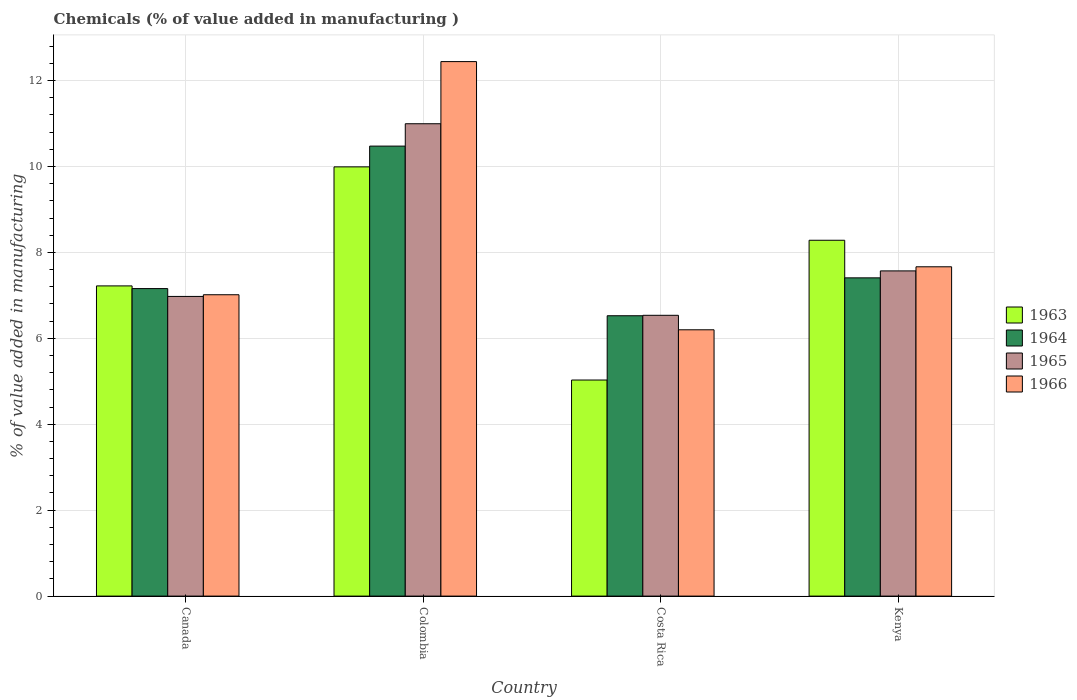How many groups of bars are there?
Your answer should be compact. 4. Are the number of bars per tick equal to the number of legend labels?
Make the answer very short. Yes. Are the number of bars on each tick of the X-axis equal?
Offer a very short reply. Yes. What is the label of the 3rd group of bars from the left?
Offer a very short reply. Costa Rica. What is the value added in manufacturing chemicals in 1964 in Costa Rica?
Offer a terse response. 6.53. Across all countries, what is the maximum value added in manufacturing chemicals in 1966?
Provide a succinct answer. 12.44. Across all countries, what is the minimum value added in manufacturing chemicals in 1965?
Your answer should be compact. 6.54. In which country was the value added in manufacturing chemicals in 1963 maximum?
Your answer should be compact. Colombia. What is the total value added in manufacturing chemicals in 1965 in the graph?
Give a very brief answer. 32.08. What is the difference between the value added in manufacturing chemicals in 1963 in Colombia and that in Kenya?
Your answer should be compact. 1.71. What is the difference between the value added in manufacturing chemicals in 1963 in Canada and the value added in manufacturing chemicals in 1964 in Costa Rica?
Provide a short and direct response. 0.69. What is the average value added in manufacturing chemicals in 1963 per country?
Ensure brevity in your answer.  7.63. What is the difference between the value added in manufacturing chemicals of/in 1966 and value added in manufacturing chemicals of/in 1964 in Kenya?
Make the answer very short. 0.26. What is the ratio of the value added in manufacturing chemicals in 1965 in Canada to that in Costa Rica?
Offer a terse response. 1.07. Is the value added in manufacturing chemicals in 1964 in Colombia less than that in Costa Rica?
Give a very brief answer. No. What is the difference between the highest and the second highest value added in manufacturing chemicals in 1966?
Give a very brief answer. -5.43. What is the difference between the highest and the lowest value added in manufacturing chemicals in 1965?
Provide a short and direct response. 4.46. What does the 4th bar from the left in Costa Rica represents?
Offer a very short reply. 1966. What does the 4th bar from the right in Costa Rica represents?
Provide a short and direct response. 1963. How many bars are there?
Your answer should be very brief. 16. How many countries are there in the graph?
Provide a short and direct response. 4. Are the values on the major ticks of Y-axis written in scientific E-notation?
Give a very brief answer. No. Does the graph contain any zero values?
Provide a succinct answer. No. Does the graph contain grids?
Provide a short and direct response. Yes. Where does the legend appear in the graph?
Keep it short and to the point. Center right. How many legend labels are there?
Offer a very short reply. 4. What is the title of the graph?
Offer a terse response. Chemicals (% of value added in manufacturing ). Does "1986" appear as one of the legend labels in the graph?
Offer a terse response. No. What is the label or title of the Y-axis?
Keep it short and to the point. % of value added in manufacturing. What is the % of value added in manufacturing of 1963 in Canada?
Ensure brevity in your answer.  7.22. What is the % of value added in manufacturing of 1964 in Canada?
Keep it short and to the point. 7.16. What is the % of value added in manufacturing of 1965 in Canada?
Ensure brevity in your answer.  6.98. What is the % of value added in manufacturing in 1966 in Canada?
Provide a succinct answer. 7.01. What is the % of value added in manufacturing of 1963 in Colombia?
Offer a very short reply. 9.99. What is the % of value added in manufacturing of 1964 in Colombia?
Give a very brief answer. 10.47. What is the % of value added in manufacturing in 1965 in Colombia?
Give a very brief answer. 10.99. What is the % of value added in manufacturing in 1966 in Colombia?
Provide a short and direct response. 12.44. What is the % of value added in manufacturing of 1963 in Costa Rica?
Your response must be concise. 5.03. What is the % of value added in manufacturing in 1964 in Costa Rica?
Provide a short and direct response. 6.53. What is the % of value added in manufacturing of 1965 in Costa Rica?
Your response must be concise. 6.54. What is the % of value added in manufacturing of 1966 in Costa Rica?
Your answer should be very brief. 6.2. What is the % of value added in manufacturing in 1963 in Kenya?
Ensure brevity in your answer.  8.28. What is the % of value added in manufacturing in 1964 in Kenya?
Provide a short and direct response. 7.41. What is the % of value added in manufacturing of 1965 in Kenya?
Give a very brief answer. 7.57. What is the % of value added in manufacturing of 1966 in Kenya?
Ensure brevity in your answer.  7.67. Across all countries, what is the maximum % of value added in manufacturing of 1963?
Offer a terse response. 9.99. Across all countries, what is the maximum % of value added in manufacturing of 1964?
Your answer should be very brief. 10.47. Across all countries, what is the maximum % of value added in manufacturing in 1965?
Provide a succinct answer. 10.99. Across all countries, what is the maximum % of value added in manufacturing of 1966?
Ensure brevity in your answer.  12.44. Across all countries, what is the minimum % of value added in manufacturing of 1963?
Keep it short and to the point. 5.03. Across all countries, what is the minimum % of value added in manufacturing of 1964?
Your answer should be compact. 6.53. Across all countries, what is the minimum % of value added in manufacturing in 1965?
Provide a short and direct response. 6.54. Across all countries, what is the minimum % of value added in manufacturing in 1966?
Provide a short and direct response. 6.2. What is the total % of value added in manufacturing of 1963 in the graph?
Ensure brevity in your answer.  30.52. What is the total % of value added in manufacturing of 1964 in the graph?
Your response must be concise. 31.57. What is the total % of value added in manufacturing of 1965 in the graph?
Provide a short and direct response. 32.08. What is the total % of value added in manufacturing in 1966 in the graph?
Ensure brevity in your answer.  33.32. What is the difference between the % of value added in manufacturing of 1963 in Canada and that in Colombia?
Provide a succinct answer. -2.77. What is the difference between the % of value added in manufacturing of 1964 in Canada and that in Colombia?
Keep it short and to the point. -3.32. What is the difference between the % of value added in manufacturing of 1965 in Canada and that in Colombia?
Your answer should be very brief. -4.02. What is the difference between the % of value added in manufacturing of 1966 in Canada and that in Colombia?
Give a very brief answer. -5.43. What is the difference between the % of value added in manufacturing in 1963 in Canada and that in Costa Rica?
Make the answer very short. 2.19. What is the difference between the % of value added in manufacturing in 1964 in Canada and that in Costa Rica?
Your answer should be very brief. 0.63. What is the difference between the % of value added in manufacturing in 1965 in Canada and that in Costa Rica?
Give a very brief answer. 0.44. What is the difference between the % of value added in manufacturing in 1966 in Canada and that in Costa Rica?
Offer a very short reply. 0.82. What is the difference between the % of value added in manufacturing of 1963 in Canada and that in Kenya?
Offer a very short reply. -1.06. What is the difference between the % of value added in manufacturing in 1964 in Canada and that in Kenya?
Your answer should be compact. -0.25. What is the difference between the % of value added in manufacturing in 1965 in Canada and that in Kenya?
Your response must be concise. -0.59. What is the difference between the % of value added in manufacturing in 1966 in Canada and that in Kenya?
Your answer should be very brief. -0.65. What is the difference between the % of value added in manufacturing of 1963 in Colombia and that in Costa Rica?
Your answer should be compact. 4.96. What is the difference between the % of value added in manufacturing in 1964 in Colombia and that in Costa Rica?
Offer a very short reply. 3.95. What is the difference between the % of value added in manufacturing in 1965 in Colombia and that in Costa Rica?
Make the answer very short. 4.46. What is the difference between the % of value added in manufacturing in 1966 in Colombia and that in Costa Rica?
Offer a terse response. 6.24. What is the difference between the % of value added in manufacturing in 1963 in Colombia and that in Kenya?
Provide a short and direct response. 1.71. What is the difference between the % of value added in manufacturing of 1964 in Colombia and that in Kenya?
Offer a very short reply. 3.07. What is the difference between the % of value added in manufacturing of 1965 in Colombia and that in Kenya?
Your response must be concise. 3.43. What is the difference between the % of value added in manufacturing of 1966 in Colombia and that in Kenya?
Give a very brief answer. 4.78. What is the difference between the % of value added in manufacturing of 1963 in Costa Rica and that in Kenya?
Your response must be concise. -3.25. What is the difference between the % of value added in manufacturing of 1964 in Costa Rica and that in Kenya?
Give a very brief answer. -0.88. What is the difference between the % of value added in manufacturing in 1965 in Costa Rica and that in Kenya?
Offer a terse response. -1.03. What is the difference between the % of value added in manufacturing of 1966 in Costa Rica and that in Kenya?
Your answer should be compact. -1.47. What is the difference between the % of value added in manufacturing in 1963 in Canada and the % of value added in manufacturing in 1964 in Colombia?
Your response must be concise. -3.25. What is the difference between the % of value added in manufacturing of 1963 in Canada and the % of value added in manufacturing of 1965 in Colombia?
Provide a succinct answer. -3.77. What is the difference between the % of value added in manufacturing of 1963 in Canada and the % of value added in manufacturing of 1966 in Colombia?
Your response must be concise. -5.22. What is the difference between the % of value added in manufacturing in 1964 in Canada and the % of value added in manufacturing in 1965 in Colombia?
Your answer should be very brief. -3.84. What is the difference between the % of value added in manufacturing of 1964 in Canada and the % of value added in manufacturing of 1966 in Colombia?
Your answer should be very brief. -5.28. What is the difference between the % of value added in manufacturing of 1965 in Canada and the % of value added in manufacturing of 1966 in Colombia?
Your answer should be very brief. -5.47. What is the difference between the % of value added in manufacturing of 1963 in Canada and the % of value added in manufacturing of 1964 in Costa Rica?
Provide a short and direct response. 0.69. What is the difference between the % of value added in manufacturing in 1963 in Canada and the % of value added in manufacturing in 1965 in Costa Rica?
Offer a terse response. 0.68. What is the difference between the % of value added in manufacturing of 1963 in Canada and the % of value added in manufacturing of 1966 in Costa Rica?
Provide a short and direct response. 1.02. What is the difference between the % of value added in manufacturing in 1964 in Canada and the % of value added in manufacturing in 1965 in Costa Rica?
Keep it short and to the point. 0.62. What is the difference between the % of value added in manufacturing of 1964 in Canada and the % of value added in manufacturing of 1966 in Costa Rica?
Your answer should be very brief. 0.96. What is the difference between the % of value added in manufacturing in 1965 in Canada and the % of value added in manufacturing in 1966 in Costa Rica?
Offer a terse response. 0.78. What is the difference between the % of value added in manufacturing of 1963 in Canada and the % of value added in manufacturing of 1964 in Kenya?
Your answer should be compact. -0.19. What is the difference between the % of value added in manufacturing in 1963 in Canada and the % of value added in manufacturing in 1965 in Kenya?
Offer a terse response. -0.35. What is the difference between the % of value added in manufacturing of 1963 in Canada and the % of value added in manufacturing of 1966 in Kenya?
Provide a succinct answer. -0.44. What is the difference between the % of value added in manufacturing of 1964 in Canada and the % of value added in manufacturing of 1965 in Kenya?
Provide a succinct answer. -0.41. What is the difference between the % of value added in manufacturing in 1964 in Canada and the % of value added in manufacturing in 1966 in Kenya?
Offer a terse response. -0.51. What is the difference between the % of value added in manufacturing of 1965 in Canada and the % of value added in manufacturing of 1966 in Kenya?
Provide a short and direct response. -0.69. What is the difference between the % of value added in manufacturing of 1963 in Colombia and the % of value added in manufacturing of 1964 in Costa Rica?
Give a very brief answer. 3.47. What is the difference between the % of value added in manufacturing in 1963 in Colombia and the % of value added in manufacturing in 1965 in Costa Rica?
Make the answer very short. 3.46. What is the difference between the % of value added in manufacturing of 1963 in Colombia and the % of value added in manufacturing of 1966 in Costa Rica?
Make the answer very short. 3.79. What is the difference between the % of value added in manufacturing in 1964 in Colombia and the % of value added in manufacturing in 1965 in Costa Rica?
Keep it short and to the point. 3.94. What is the difference between the % of value added in manufacturing of 1964 in Colombia and the % of value added in manufacturing of 1966 in Costa Rica?
Your answer should be compact. 4.28. What is the difference between the % of value added in manufacturing of 1965 in Colombia and the % of value added in manufacturing of 1966 in Costa Rica?
Your answer should be compact. 4.8. What is the difference between the % of value added in manufacturing in 1963 in Colombia and the % of value added in manufacturing in 1964 in Kenya?
Your response must be concise. 2.58. What is the difference between the % of value added in manufacturing in 1963 in Colombia and the % of value added in manufacturing in 1965 in Kenya?
Provide a succinct answer. 2.42. What is the difference between the % of value added in manufacturing in 1963 in Colombia and the % of value added in manufacturing in 1966 in Kenya?
Provide a succinct answer. 2.33. What is the difference between the % of value added in manufacturing of 1964 in Colombia and the % of value added in manufacturing of 1965 in Kenya?
Your answer should be very brief. 2.9. What is the difference between the % of value added in manufacturing in 1964 in Colombia and the % of value added in manufacturing in 1966 in Kenya?
Your response must be concise. 2.81. What is the difference between the % of value added in manufacturing in 1965 in Colombia and the % of value added in manufacturing in 1966 in Kenya?
Offer a terse response. 3.33. What is the difference between the % of value added in manufacturing of 1963 in Costa Rica and the % of value added in manufacturing of 1964 in Kenya?
Your response must be concise. -2.38. What is the difference between the % of value added in manufacturing of 1963 in Costa Rica and the % of value added in manufacturing of 1965 in Kenya?
Your answer should be very brief. -2.54. What is the difference between the % of value added in manufacturing of 1963 in Costa Rica and the % of value added in manufacturing of 1966 in Kenya?
Offer a terse response. -2.64. What is the difference between the % of value added in manufacturing in 1964 in Costa Rica and the % of value added in manufacturing in 1965 in Kenya?
Keep it short and to the point. -1.04. What is the difference between the % of value added in manufacturing in 1964 in Costa Rica and the % of value added in manufacturing in 1966 in Kenya?
Provide a short and direct response. -1.14. What is the difference between the % of value added in manufacturing in 1965 in Costa Rica and the % of value added in manufacturing in 1966 in Kenya?
Your response must be concise. -1.13. What is the average % of value added in manufacturing of 1963 per country?
Your answer should be compact. 7.63. What is the average % of value added in manufacturing in 1964 per country?
Your answer should be compact. 7.89. What is the average % of value added in manufacturing of 1965 per country?
Give a very brief answer. 8.02. What is the average % of value added in manufacturing of 1966 per country?
Ensure brevity in your answer.  8.33. What is the difference between the % of value added in manufacturing in 1963 and % of value added in manufacturing in 1964 in Canada?
Provide a short and direct response. 0.06. What is the difference between the % of value added in manufacturing in 1963 and % of value added in manufacturing in 1965 in Canada?
Offer a very short reply. 0.25. What is the difference between the % of value added in manufacturing of 1963 and % of value added in manufacturing of 1966 in Canada?
Make the answer very short. 0.21. What is the difference between the % of value added in manufacturing in 1964 and % of value added in manufacturing in 1965 in Canada?
Keep it short and to the point. 0.18. What is the difference between the % of value added in manufacturing in 1964 and % of value added in manufacturing in 1966 in Canada?
Ensure brevity in your answer.  0.14. What is the difference between the % of value added in manufacturing of 1965 and % of value added in manufacturing of 1966 in Canada?
Your response must be concise. -0.04. What is the difference between the % of value added in manufacturing in 1963 and % of value added in manufacturing in 1964 in Colombia?
Provide a succinct answer. -0.48. What is the difference between the % of value added in manufacturing in 1963 and % of value added in manufacturing in 1965 in Colombia?
Offer a very short reply. -1. What is the difference between the % of value added in manufacturing of 1963 and % of value added in manufacturing of 1966 in Colombia?
Provide a short and direct response. -2.45. What is the difference between the % of value added in manufacturing of 1964 and % of value added in manufacturing of 1965 in Colombia?
Provide a short and direct response. -0.52. What is the difference between the % of value added in manufacturing of 1964 and % of value added in manufacturing of 1966 in Colombia?
Offer a terse response. -1.97. What is the difference between the % of value added in manufacturing of 1965 and % of value added in manufacturing of 1966 in Colombia?
Your answer should be very brief. -1.45. What is the difference between the % of value added in manufacturing of 1963 and % of value added in manufacturing of 1964 in Costa Rica?
Provide a succinct answer. -1.5. What is the difference between the % of value added in manufacturing of 1963 and % of value added in manufacturing of 1965 in Costa Rica?
Your answer should be very brief. -1.51. What is the difference between the % of value added in manufacturing of 1963 and % of value added in manufacturing of 1966 in Costa Rica?
Your response must be concise. -1.17. What is the difference between the % of value added in manufacturing of 1964 and % of value added in manufacturing of 1965 in Costa Rica?
Provide a short and direct response. -0.01. What is the difference between the % of value added in manufacturing in 1964 and % of value added in manufacturing in 1966 in Costa Rica?
Your answer should be very brief. 0.33. What is the difference between the % of value added in manufacturing in 1965 and % of value added in manufacturing in 1966 in Costa Rica?
Your response must be concise. 0.34. What is the difference between the % of value added in manufacturing of 1963 and % of value added in manufacturing of 1964 in Kenya?
Offer a very short reply. 0.87. What is the difference between the % of value added in manufacturing in 1963 and % of value added in manufacturing in 1965 in Kenya?
Your answer should be compact. 0.71. What is the difference between the % of value added in manufacturing of 1963 and % of value added in manufacturing of 1966 in Kenya?
Ensure brevity in your answer.  0.62. What is the difference between the % of value added in manufacturing of 1964 and % of value added in manufacturing of 1965 in Kenya?
Provide a short and direct response. -0.16. What is the difference between the % of value added in manufacturing of 1964 and % of value added in manufacturing of 1966 in Kenya?
Your answer should be very brief. -0.26. What is the difference between the % of value added in manufacturing in 1965 and % of value added in manufacturing in 1966 in Kenya?
Give a very brief answer. -0.1. What is the ratio of the % of value added in manufacturing of 1963 in Canada to that in Colombia?
Provide a succinct answer. 0.72. What is the ratio of the % of value added in manufacturing of 1964 in Canada to that in Colombia?
Offer a very short reply. 0.68. What is the ratio of the % of value added in manufacturing in 1965 in Canada to that in Colombia?
Make the answer very short. 0.63. What is the ratio of the % of value added in manufacturing of 1966 in Canada to that in Colombia?
Make the answer very short. 0.56. What is the ratio of the % of value added in manufacturing in 1963 in Canada to that in Costa Rica?
Give a very brief answer. 1.44. What is the ratio of the % of value added in manufacturing in 1964 in Canada to that in Costa Rica?
Keep it short and to the point. 1.1. What is the ratio of the % of value added in manufacturing in 1965 in Canada to that in Costa Rica?
Offer a terse response. 1.07. What is the ratio of the % of value added in manufacturing in 1966 in Canada to that in Costa Rica?
Offer a terse response. 1.13. What is the ratio of the % of value added in manufacturing of 1963 in Canada to that in Kenya?
Make the answer very short. 0.87. What is the ratio of the % of value added in manufacturing of 1964 in Canada to that in Kenya?
Provide a succinct answer. 0.97. What is the ratio of the % of value added in manufacturing of 1965 in Canada to that in Kenya?
Your answer should be compact. 0.92. What is the ratio of the % of value added in manufacturing of 1966 in Canada to that in Kenya?
Your answer should be compact. 0.92. What is the ratio of the % of value added in manufacturing in 1963 in Colombia to that in Costa Rica?
Make the answer very short. 1.99. What is the ratio of the % of value added in manufacturing in 1964 in Colombia to that in Costa Rica?
Provide a short and direct response. 1.61. What is the ratio of the % of value added in manufacturing of 1965 in Colombia to that in Costa Rica?
Ensure brevity in your answer.  1.68. What is the ratio of the % of value added in manufacturing of 1966 in Colombia to that in Costa Rica?
Ensure brevity in your answer.  2.01. What is the ratio of the % of value added in manufacturing of 1963 in Colombia to that in Kenya?
Your response must be concise. 1.21. What is the ratio of the % of value added in manufacturing in 1964 in Colombia to that in Kenya?
Offer a terse response. 1.41. What is the ratio of the % of value added in manufacturing in 1965 in Colombia to that in Kenya?
Your response must be concise. 1.45. What is the ratio of the % of value added in manufacturing of 1966 in Colombia to that in Kenya?
Give a very brief answer. 1.62. What is the ratio of the % of value added in manufacturing in 1963 in Costa Rica to that in Kenya?
Offer a terse response. 0.61. What is the ratio of the % of value added in manufacturing of 1964 in Costa Rica to that in Kenya?
Your response must be concise. 0.88. What is the ratio of the % of value added in manufacturing of 1965 in Costa Rica to that in Kenya?
Offer a very short reply. 0.86. What is the ratio of the % of value added in manufacturing in 1966 in Costa Rica to that in Kenya?
Offer a terse response. 0.81. What is the difference between the highest and the second highest % of value added in manufacturing in 1963?
Offer a terse response. 1.71. What is the difference between the highest and the second highest % of value added in manufacturing in 1964?
Your answer should be very brief. 3.07. What is the difference between the highest and the second highest % of value added in manufacturing of 1965?
Provide a succinct answer. 3.43. What is the difference between the highest and the second highest % of value added in manufacturing of 1966?
Provide a short and direct response. 4.78. What is the difference between the highest and the lowest % of value added in manufacturing in 1963?
Offer a terse response. 4.96. What is the difference between the highest and the lowest % of value added in manufacturing of 1964?
Offer a very short reply. 3.95. What is the difference between the highest and the lowest % of value added in manufacturing of 1965?
Give a very brief answer. 4.46. What is the difference between the highest and the lowest % of value added in manufacturing of 1966?
Ensure brevity in your answer.  6.24. 